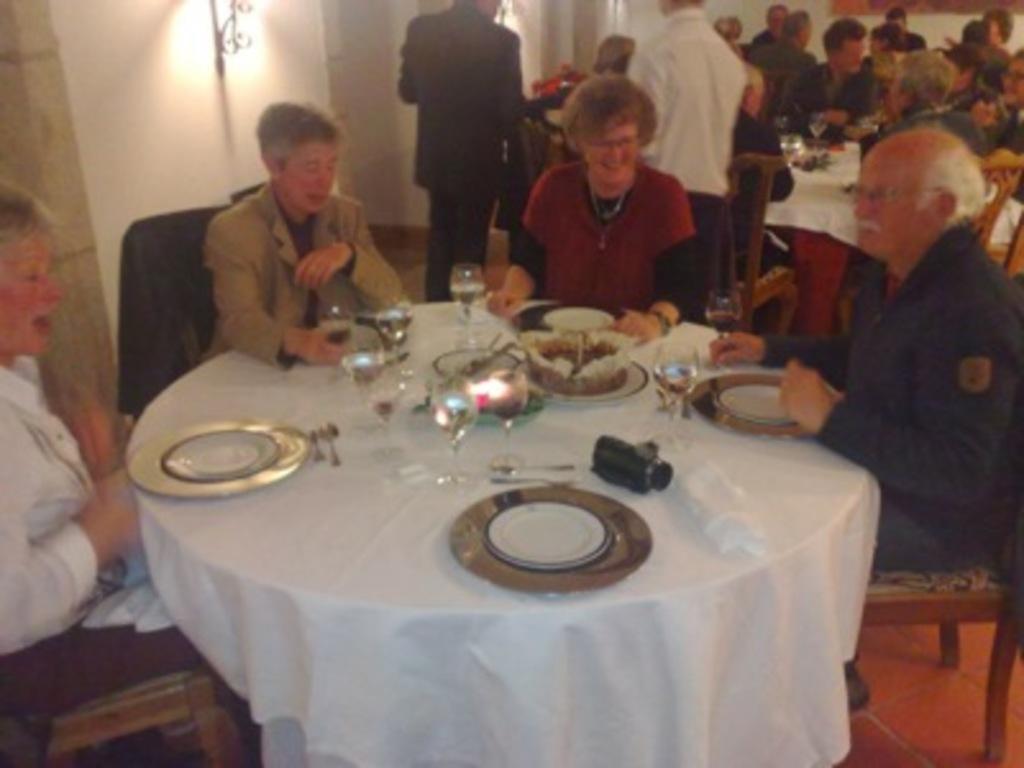Please provide a concise description of this image. In the middle there is a table on the table there is a plate,glass ,spoon and fork , in front of that table there are four people sitting on the chairs ,On that in the middle there is a woman she is smiling her hair is short. On the right there is a man he wear black shirt and trouser. In the back ground there is a table in front of that table there many people sitting on the chairs. In the background there are many people. On the left there is a wall and light. 